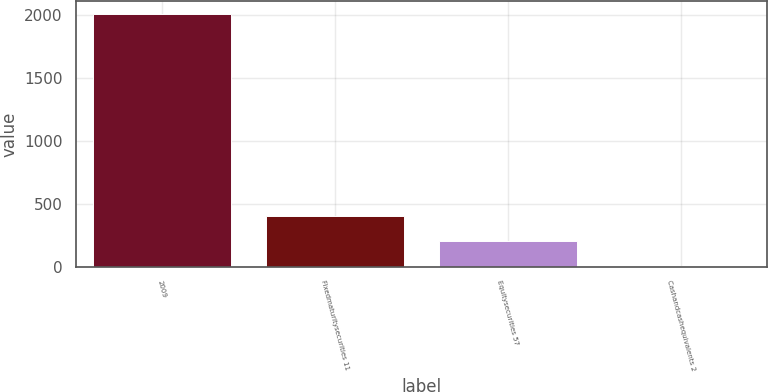<chart> <loc_0><loc_0><loc_500><loc_500><bar_chart><fcel>2009<fcel>Fixedmaturitysecurities 11<fcel>Equitysecurities 57<fcel>Cashandcashequivalents 2<nl><fcel>2008<fcel>404<fcel>203.5<fcel>3<nl></chart> 